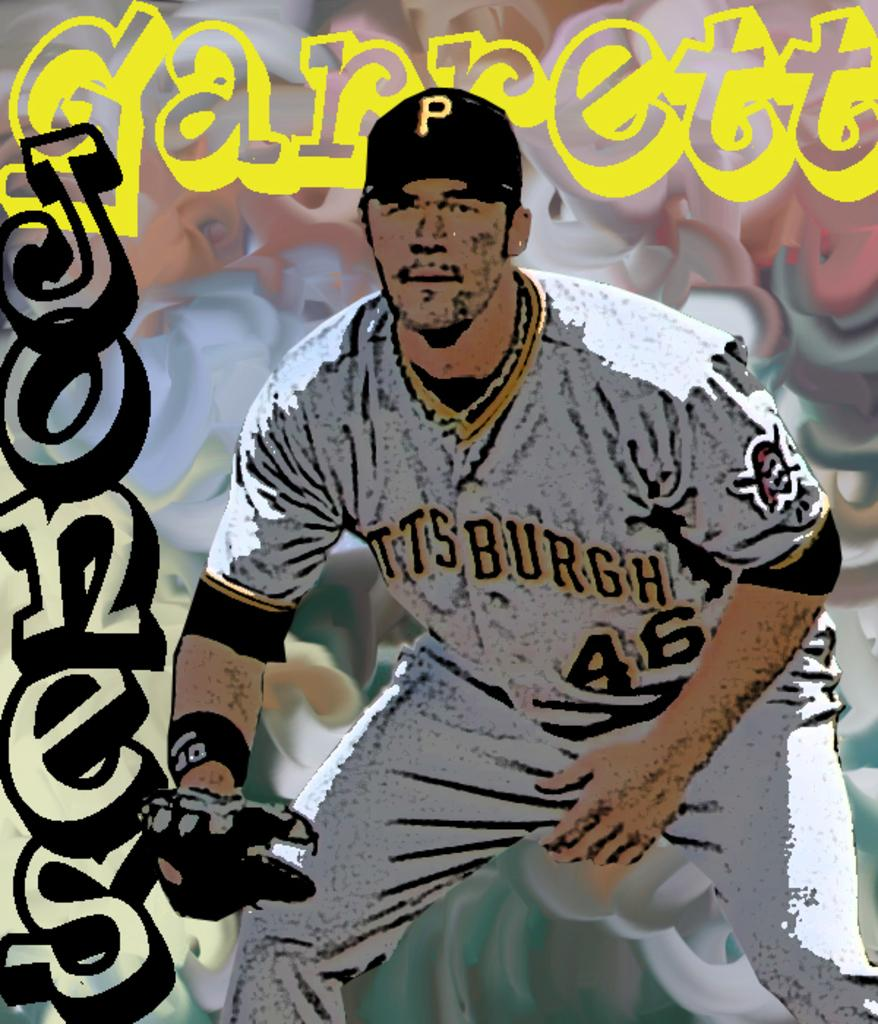Provide a one-sentence caption for the provided image. A simulated drawing of a Pittsburgh baseball player. 